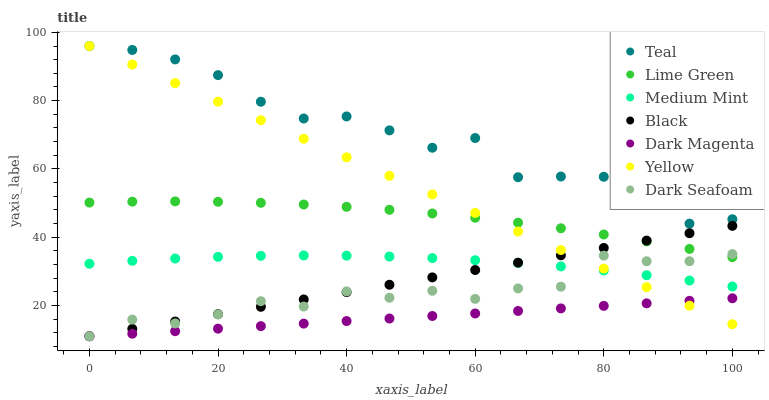Does Dark Magenta have the minimum area under the curve?
Answer yes or no. Yes. Does Teal have the maximum area under the curve?
Answer yes or no. Yes. Does Yellow have the minimum area under the curve?
Answer yes or no. No. Does Yellow have the maximum area under the curve?
Answer yes or no. No. Is Dark Magenta the smoothest?
Answer yes or no. Yes. Is Teal the roughest?
Answer yes or no. Yes. Is Yellow the smoothest?
Answer yes or no. No. Is Yellow the roughest?
Answer yes or no. No. Does Dark Magenta have the lowest value?
Answer yes or no. Yes. Does Yellow have the lowest value?
Answer yes or no. No. Does Teal have the highest value?
Answer yes or no. Yes. Does Dark Magenta have the highest value?
Answer yes or no. No. Is Dark Seafoam less than Teal?
Answer yes or no. Yes. Is Teal greater than Dark Magenta?
Answer yes or no. Yes. Does Yellow intersect Black?
Answer yes or no. Yes. Is Yellow less than Black?
Answer yes or no. No. Is Yellow greater than Black?
Answer yes or no. No. Does Dark Seafoam intersect Teal?
Answer yes or no. No. 